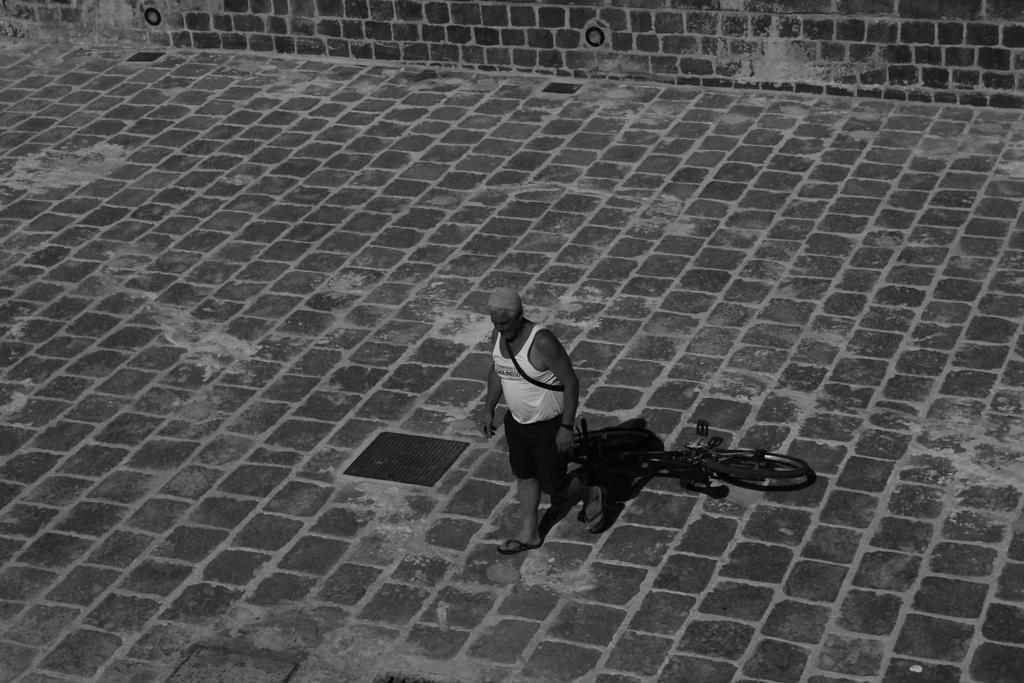Can you describe this image briefly? In this image in the center there is one person and beside him there is cycle. At the bottom there is walkway, and in the background there is wall. 